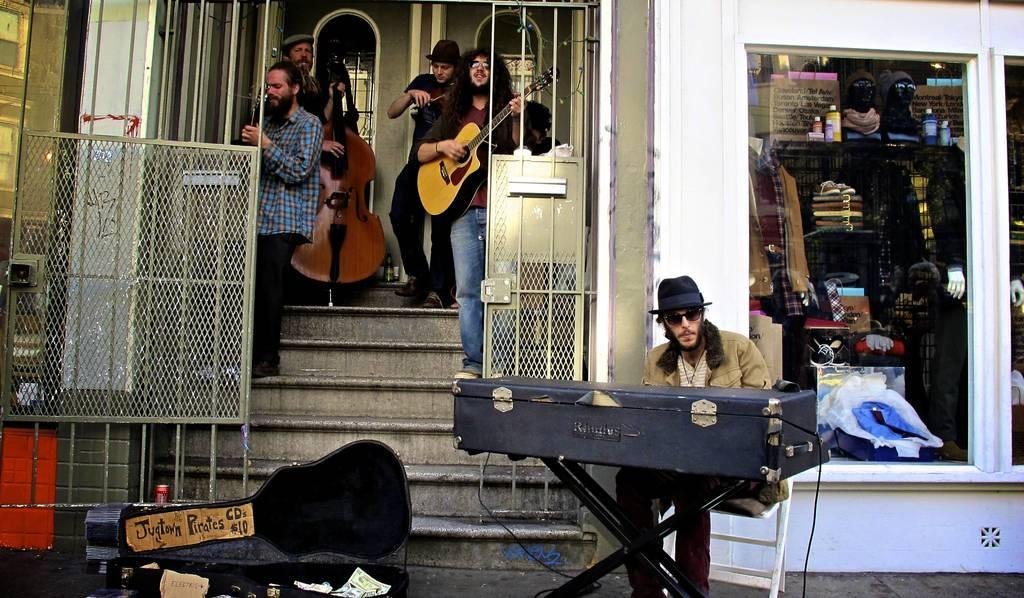How many musicians are in the band? There are five musicians in the band. Where are the musicians playing their instruments? Four musicians are playing instruments on steps, while one musician is sitting beside playing a keyboard. What type of eggnog is being served in a jar beside the band? There is no mention of eggnog or a jar in the image; the focus is on the musicians and their instruments. 